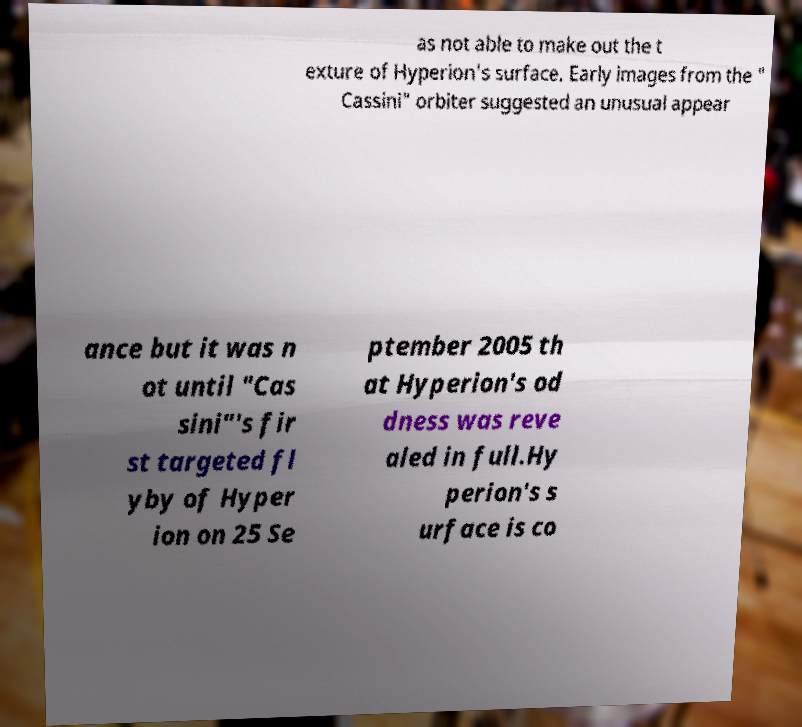What messages or text are displayed in this image? I need them in a readable, typed format. as not able to make out the t exture of Hyperion's surface. Early images from the " Cassini" orbiter suggested an unusual appear ance but it was n ot until "Cas sini"'s fir st targeted fl yby of Hyper ion on 25 Se ptember 2005 th at Hyperion's od dness was reve aled in full.Hy perion's s urface is co 